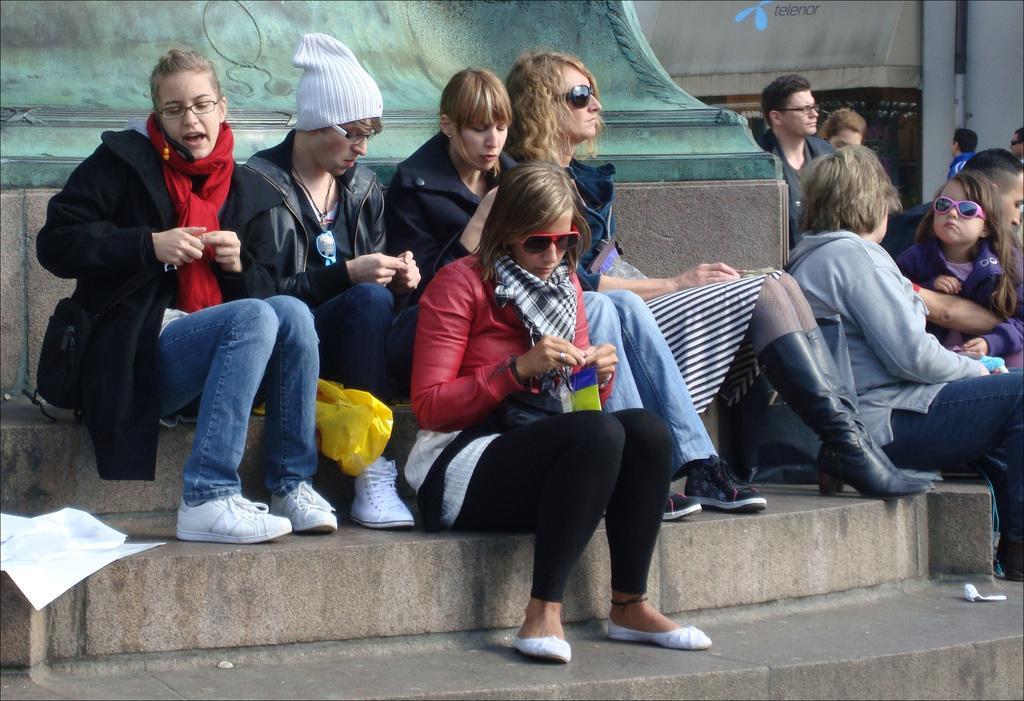Please provide a concise description of this image. In this image there are persons sitting and there are walls and there is a text written on the wall which is in the background and there is a pipe in front of the wall. In the front on the floor there are objects which are white in colour and there is a woman sitting and speaking on the phone and there are persons sitting and holding objects in their hands. 